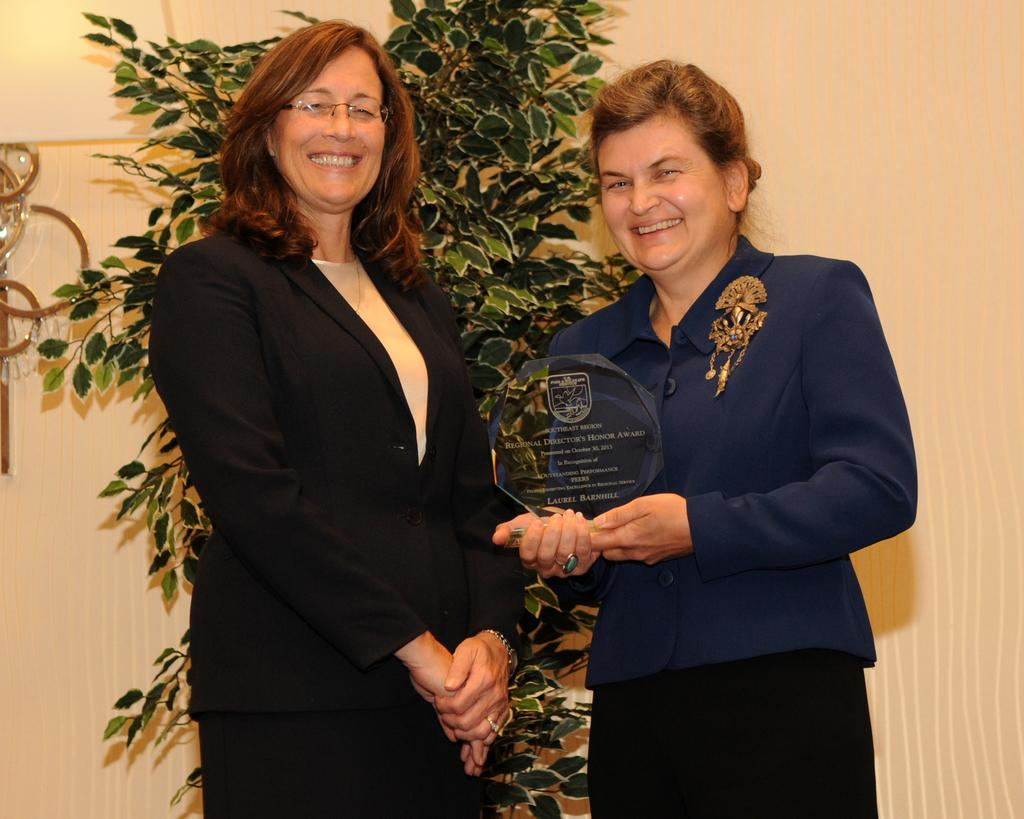How many people are in the image? There are two women in the image. What is one of the women doing in the image? One of the women is holding an object. What can be seen in the background of the image? There is a wall and a plant in the background of the image. What type of destruction is the bear causing in the image? There is no bear present in the image, and therefore no destruction can be observed. 